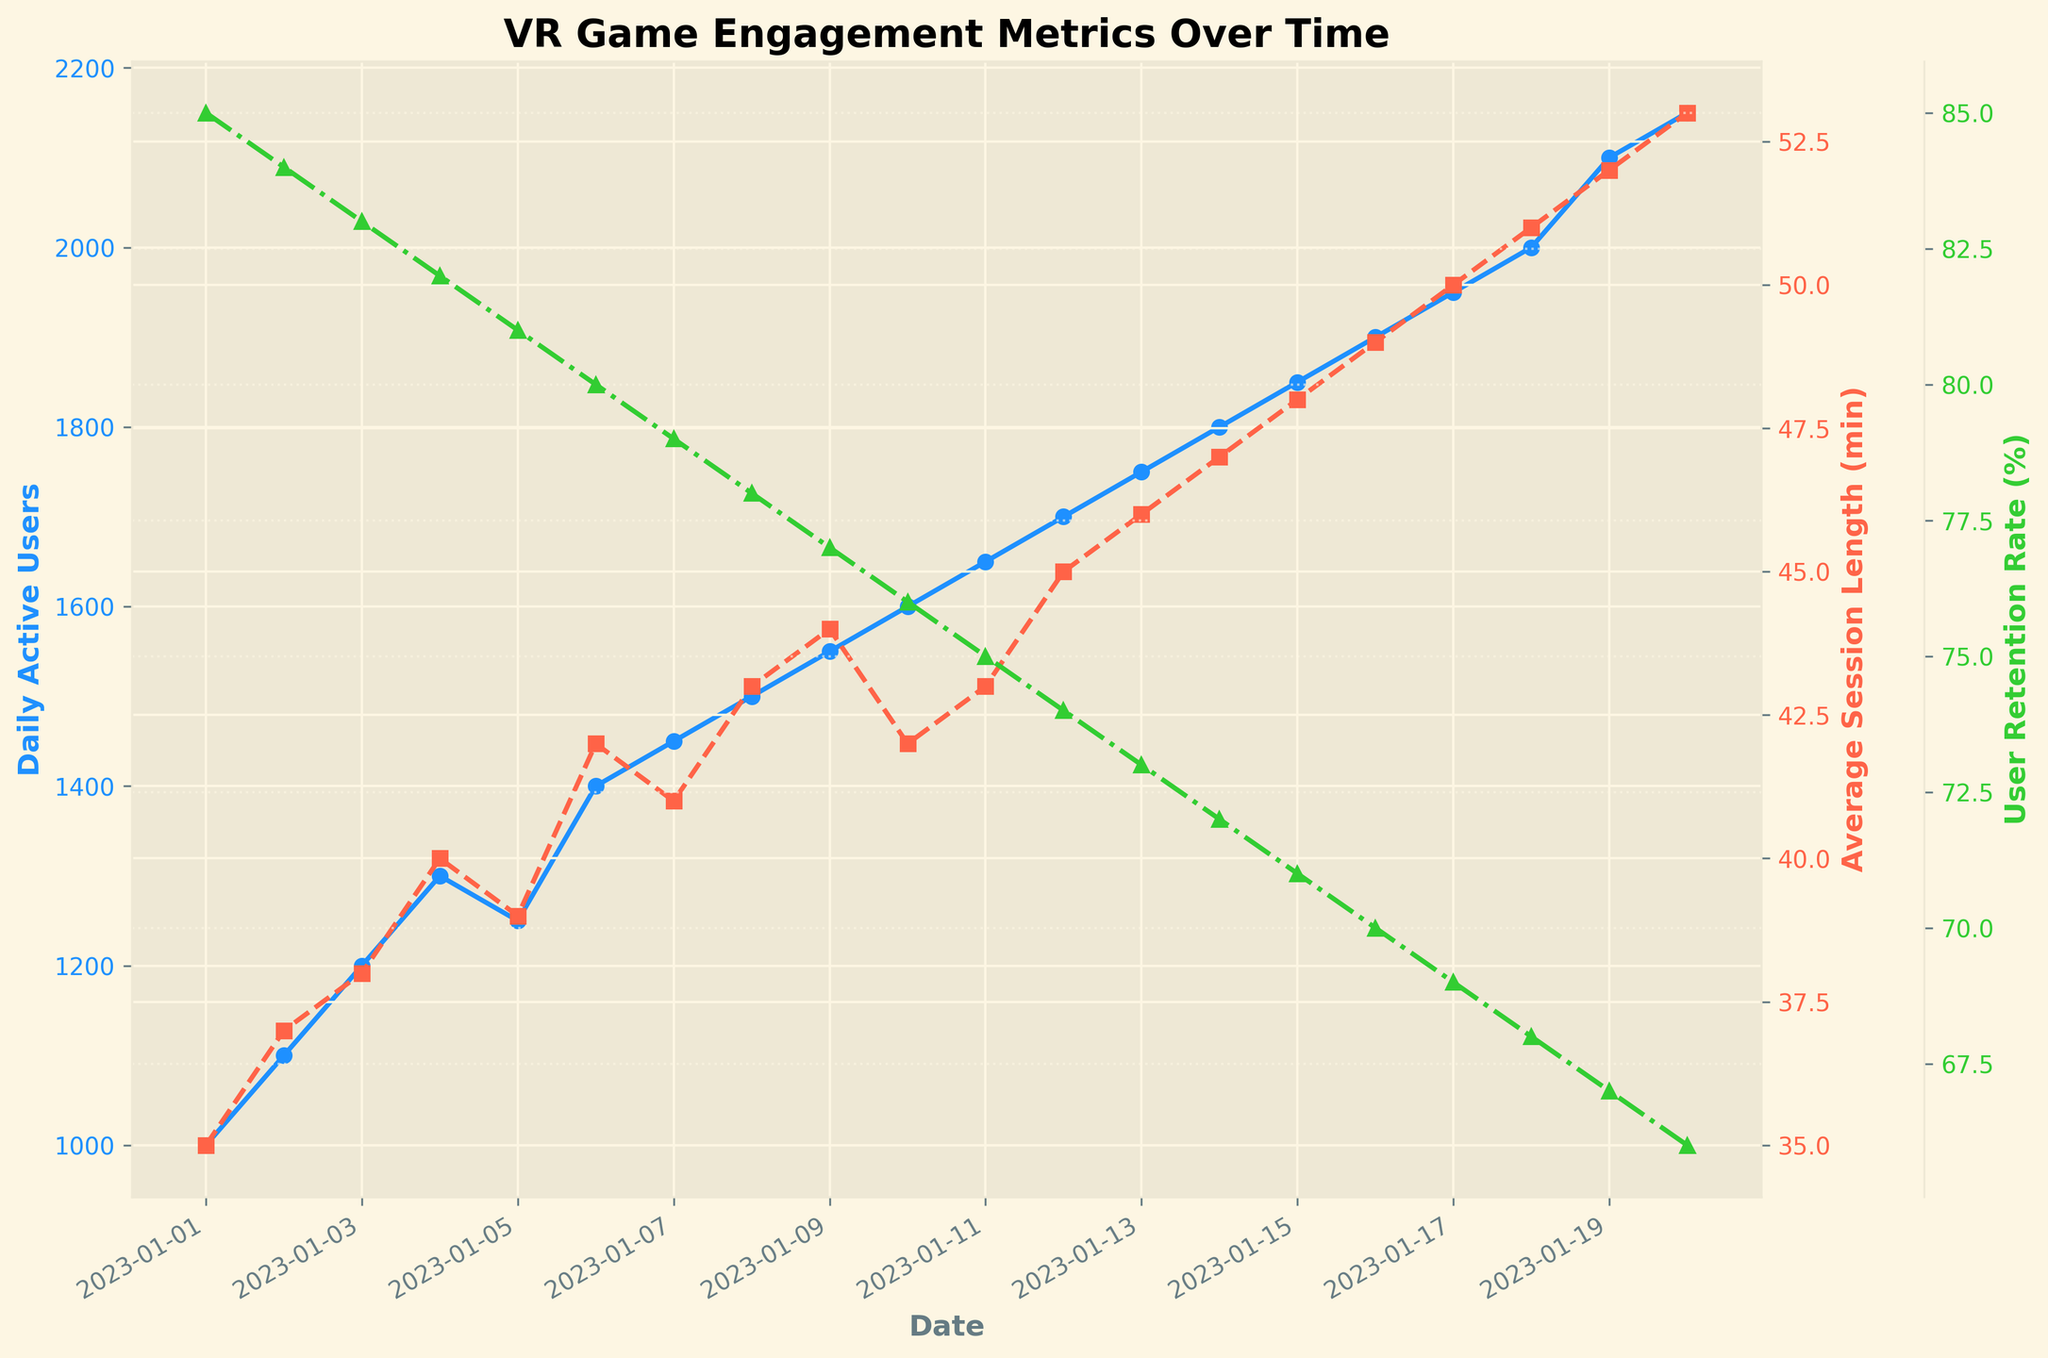What is the title of the figure? The title of the figure is usually placed at the top of the plot. By looking at the top part of the figure, we can see the title.
Answer: VR Game Engagement Metrics Over Time What are the different engagement metrics shown on the figure? The engagement metrics are displayed on the y-axes and are associated with different colors and data point markers. By examining the left and right y-axes, we can identify the metrics.
Answer: Daily active users, average session length, and user retention rate How many days of data are presented in the figure? By counting the number of data points or x-tick labels on the date axis, we can determine the number of days of data shown.
Answer: 20 What is the trend in the average session length from January 1 to January 20? By observing the plot line for the average session length (noted in the color legend and y-axis), we can see how it changes over time.
Answer: Increasing On which date did daily active users first reach 2000? By looking at the plot line for daily active users and identifying the first point where it meets or exceeds 2000 on the y-axis, we can find the corresponding date on the x-axis.
Answer: January 18, 2023 What was the user retention rate on January 5? By locating the date January 5 on the x-axis and following the plot line for user retention rate to the y-axis, we can find the value.
Answer: 81% Between January 10 and January 15, what was the total increase in daily active users? Identify the daily active user counts on January 10 and January 15, then subtract the count from January 10 from the count on January 15.
Answer: 250 Which metric shows a consistent decline over the time period? By examining the trend lines for each of the three metrics, we can identify which one shows a consistent downward trend.
Answer: User retention rate How does the user retention rate on January 20 compare to January 1? Compare the user retention rate values on both dates by looking at the y-axis values for these specific dates.
Answer: Lower on January 20 